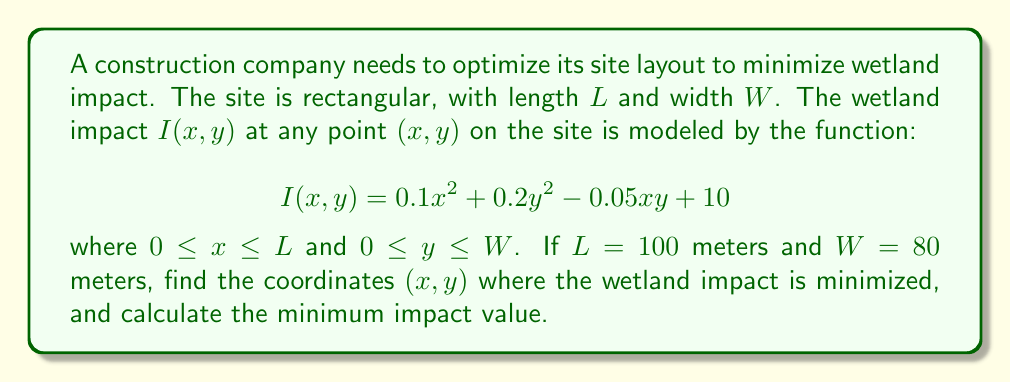Could you help me with this problem? To find the minimum wetland impact, we need to use multivariable calculus:

1) First, we find the partial derivatives of $I(x,y)$ with respect to $x$ and $y$:

   $$\frac{\partial I}{\partial x} = 0.2x - 0.05y$$
   $$\frac{\partial I}{\partial y} = 0.4y - 0.05x$$

2) Set both partial derivatives to zero to find the critical points:

   $$0.2x - 0.05y = 0$$
   $$0.4y - 0.05x = 0$$

3) Solve this system of equations:
   
   Multiply the first equation by 2 and the second by 1:
   
   $$0.4x - 0.1y = 0$$
   $$0.4y - 0.05x = 0$$
   
   Add these equations:
   
   $$0.35x = 0.1y$$
   $$x = \frac{2}{7}y$$

   Substitute this into the second original equation:
   
   $$0.4y - 0.05(\frac{2}{7}y) = 0$$
   $$0.4y - \frac{1}{70}y = 0$$
   $$\frac{27}{70}y = 0$$
   
   This gives us $y = 0$, and consequently, $x = 0$.

4) Check the boundaries:
   - At $(0,0)$: $I(0,0) = 10$
   - At $(100,0)$: $I(100,0) = 1010$
   - At $(0,80)$: $I(0,80) = 1290$
   - At $(100,80)$: $I(100,80) = 2290$

5) The second derivative test confirms that $(0,0)$ is indeed a local minimum.

6) Therefore, the minimum impact occurs at $(0,0)$ with a value of 10.
Answer: $(0,0)$; 10 